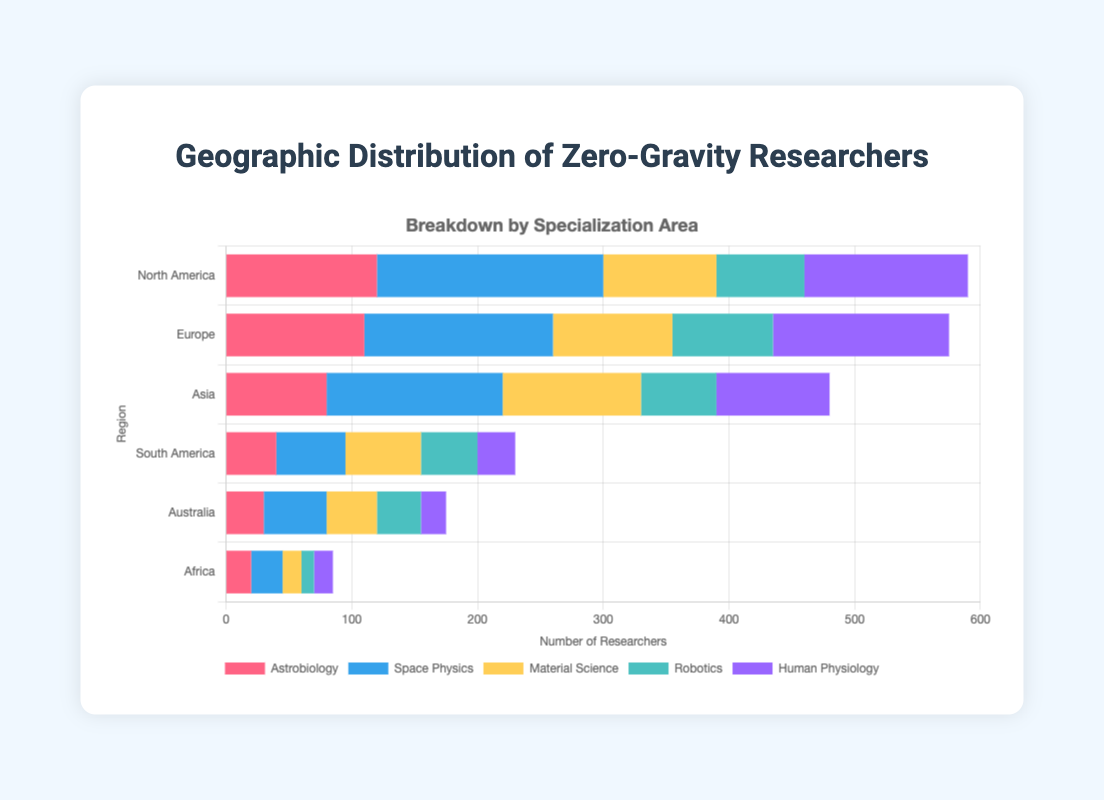Which region has the highest number of zero-gravity researchers in space physics? North America has the highest number of space physics researchers with 180. This can be observed as the longest blue bar in the space physics segment.
Answer: North America In which region do human physiology researchers outnumber astrobiology researchers? By comparing the lengths of the purple and red bars for each region, Europe has more human physiology researchers (140) than astrobiology researchers (110).
Answer: Europe What is the total number of zero-gravity researchers in North America? Sum the values for each specialization in North America: 120 (astrobiology) + 180 (space physics) + 90 (material science) + 70 (robotics) + 130 (human physiology) = 590.
Answer: 590 How does the number of robotics researchers in Asia compare to that in South America? Asia has 60 robotics researchers while South America has 45. Consequently, Asia has 15 more robotics researchers than South America.
Answer: 15 more in Asia Which specialization has the least number of researchers in Australia? By comparing the lengths of the segments within the Australia bar, human physiology has the shortest bar with 20 researchers.
Answer: Human physiology What is the average number of astrobiology researchers across all regions? Sum the number of astrobiology researchers in each region: 120 + 110 + 80 + 40 + 30 + 20 = 400. There are 6 regions, so the average is 400 / 6 = ~66.67.
Answer: ~66.67 Which region has the fewest zero-gravity researchers overall? Observing the cumulative lengths of all the bars for each region, Africa has the fewest researchers in total (20 + 25 + 15 + 10 + 15 = 85).
Answer: Africa In which region is the number of material science researchers the highest? Europe shows the highest count with 95 material science researchers, signified by the longest yellow bar in its row.
Answer: Europe What is the difference in the total number of researchers between Europe and Asia? Total in Europe: 110 + 150 + 95 + 80 + 140 = 575. Total in Asia: 80 + 140 + 110 + 60 + 90 = 480. Difference: 575 - 480 = 95.
Answer: 95 Which two specializations have a combined total of over 200 researchers in North America? Space physics (180) and human physiology (130) combined give 310, which is above 200.
Answer: Space physics and human physiology 